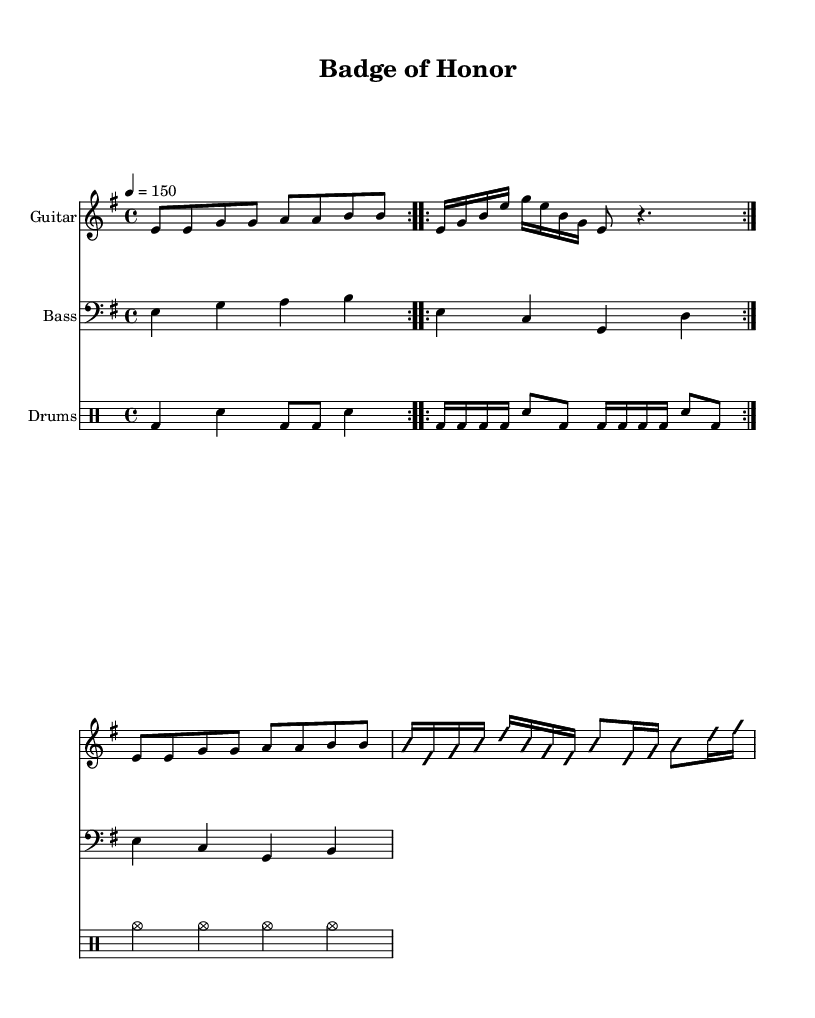What is the key signature of this music? The key signature is indicated by the number of sharps or flats at the beginning of the staff. In this score, there is one sharp, indicating it is in E minor.
Answer: E minor What is the time signature of this music? The time signature is located at the beginning of the piece. It shows that there are four beats in a measure and the quarter note gets one beat; thus, it is 4/4.
Answer: 4/4 What is the tempo marking of the piece? The tempo marking appears at the beginning of the score, indicating how fast the music should be played. Here, it states that the tempo is 150 beats per minute.
Answer: 150 How many measures are in the chorus section? By counting the measures in the chorus part of the score, you can determine how many are present. The chorus has four measures in total.
Answer: Four What type of guitar is used in this piece? The notation specifies that the highest staff is an electric guitar. This is indicated by the instrument name written on the staff.
Answer: Electric Guitar Which lyrical theme is emphasized in the chorus? The chorus expresses pride and duty, as suggested by the lyrics "Stand tall, stand proud, we're the thin blue line." This reflects the dedication of law enforcement officers.
Answer: Dedication 